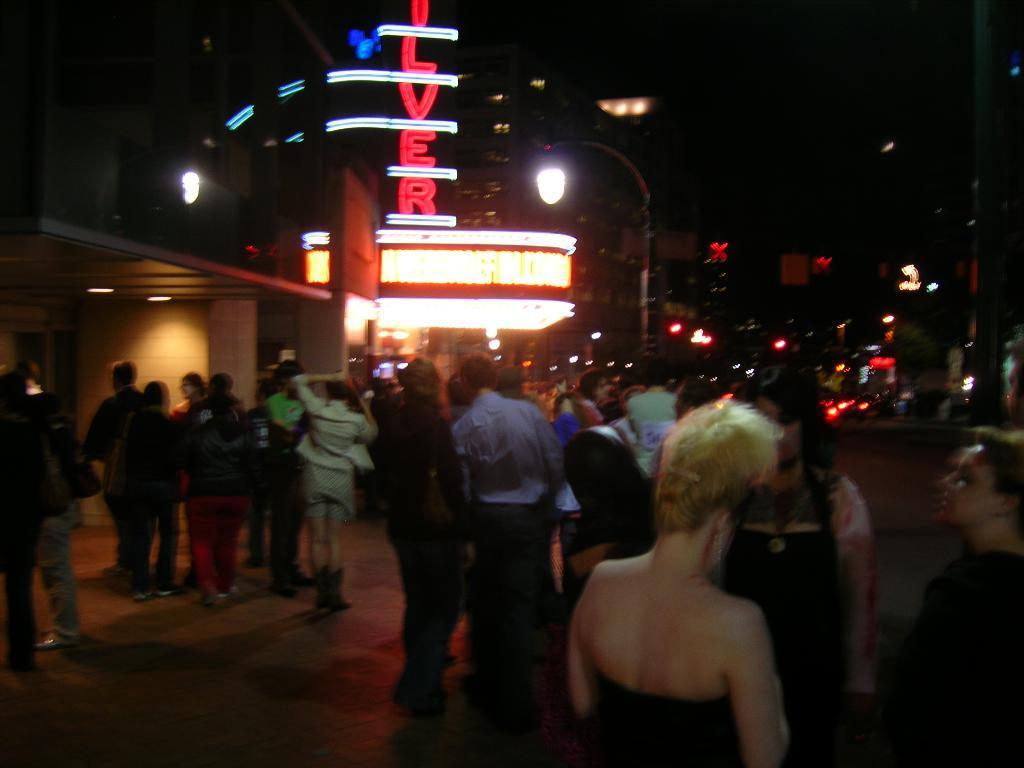How would you summarize this image in a sentence or two? This image is taken outdoors. In this image the background is dark and there are a few lights. There is a building. There are many rope lights and there is a text. In the middle of the image many people are standing on the road. At the bottom of the image there is a road. 